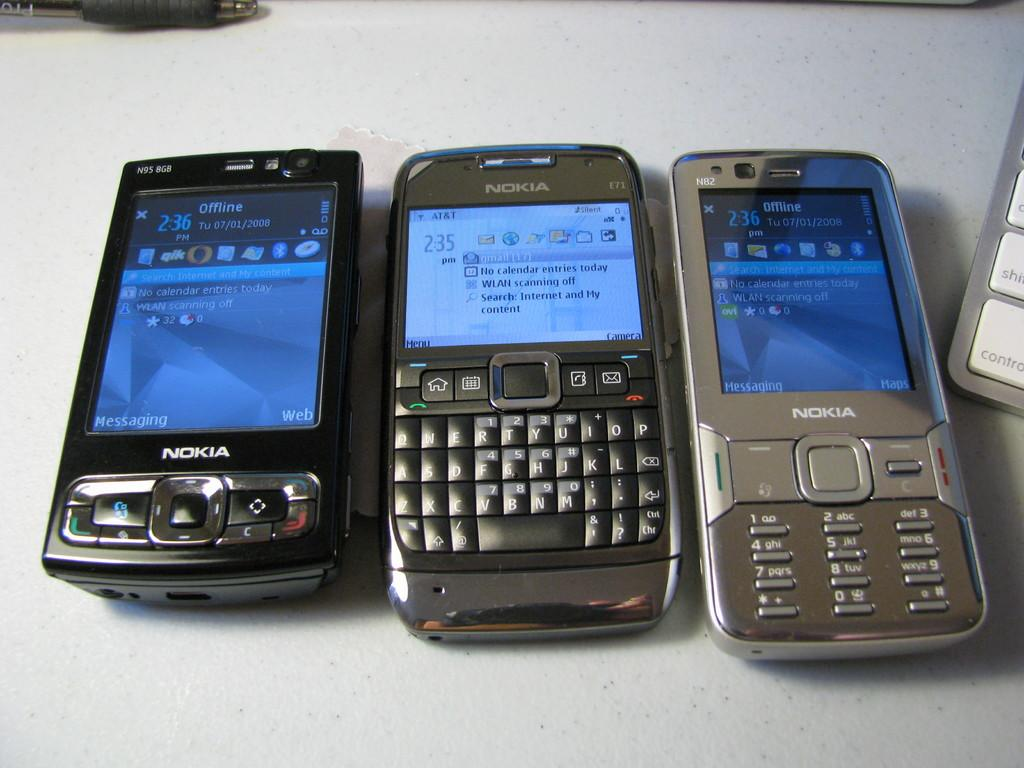<image>
Give a short and clear explanation of the subsequent image. Three Nokia cell phones sit on a table. 